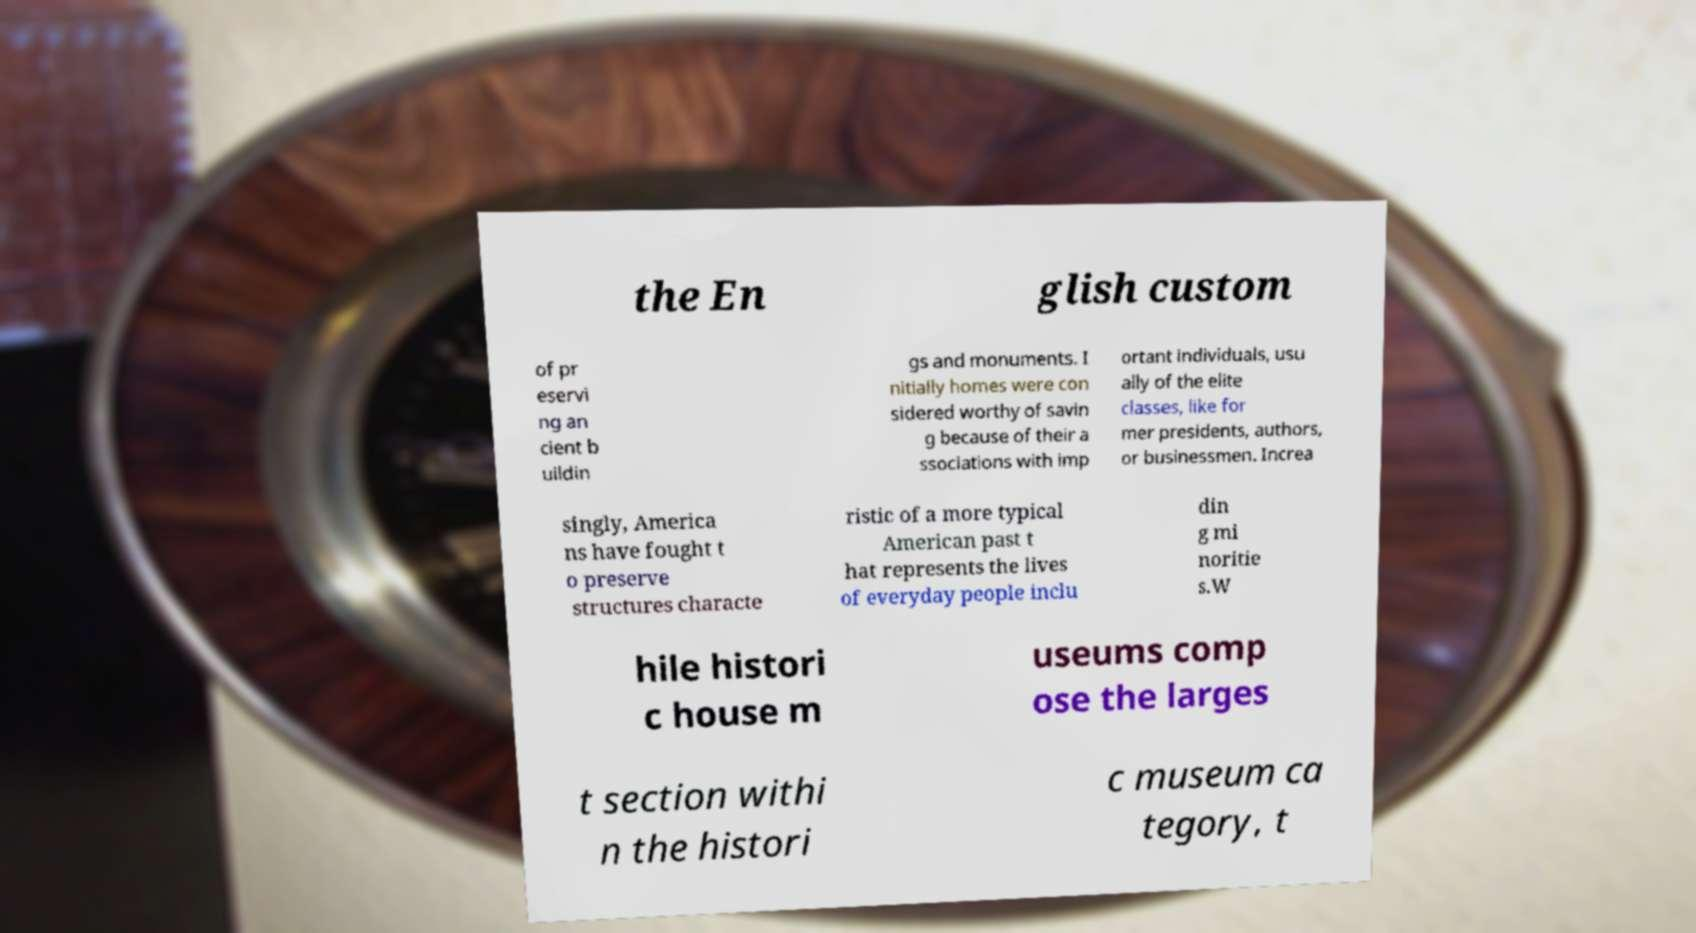Can you read and provide the text displayed in the image?This photo seems to have some interesting text. Can you extract and type it out for me? the En glish custom of pr eservi ng an cient b uildin gs and monuments. I nitially homes were con sidered worthy of savin g because of their a ssociations with imp ortant individuals, usu ally of the elite classes, like for mer presidents, authors, or businessmen. Increa singly, America ns have fought t o preserve structures characte ristic of a more typical American past t hat represents the lives of everyday people inclu din g mi noritie s.W hile histori c house m useums comp ose the larges t section withi n the histori c museum ca tegory, t 